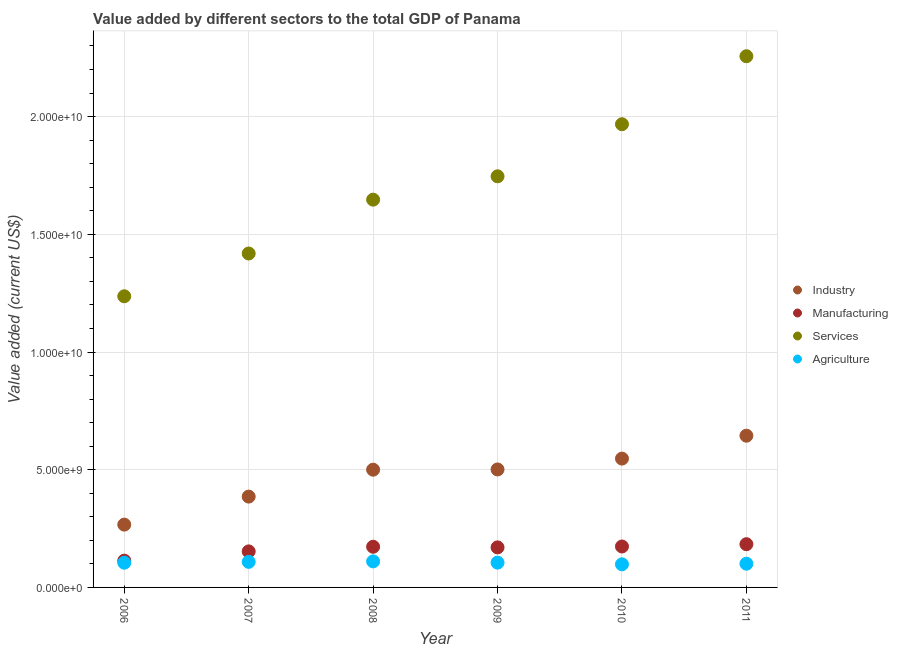Is the number of dotlines equal to the number of legend labels?
Provide a succinct answer. Yes. What is the value added by industrial sector in 2008?
Keep it short and to the point. 5.00e+09. Across all years, what is the maximum value added by manufacturing sector?
Provide a succinct answer. 1.84e+09. Across all years, what is the minimum value added by agricultural sector?
Your answer should be compact. 9.81e+08. What is the total value added by agricultural sector in the graph?
Your response must be concise. 6.29e+09. What is the difference between the value added by agricultural sector in 2006 and that in 2009?
Give a very brief answer. -3.70e+06. What is the difference between the value added by manufacturing sector in 2011 and the value added by services sector in 2006?
Give a very brief answer. -1.05e+1. What is the average value added by manufacturing sector per year?
Your response must be concise. 1.61e+09. In the year 2010, what is the difference between the value added by services sector and value added by agricultural sector?
Give a very brief answer. 1.87e+1. What is the ratio of the value added by agricultural sector in 2007 to that in 2011?
Keep it short and to the point. 1.08. Is the difference between the value added by agricultural sector in 2009 and 2011 greater than the difference between the value added by manufacturing sector in 2009 and 2011?
Make the answer very short. Yes. What is the difference between the highest and the second highest value added by manufacturing sector?
Offer a very short reply. 9.76e+07. What is the difference between the highest and the lowest value added by manufacturing sector?
Make the answer very short. 6.99e+08. In how many years, is the value added by manufacturing sector greater than the average value added by manufacturing sector taken over all years?
Give a very brief answer. 4. Is the sum of the value added by services sector in 2006 and 2007 greater than the maximum value added by industrial sector across all years?
Make the answer very short. Yes. Is it the case that in every year, the sum of the value added by agricultural sector and value added by manufacturing sector is greater than the sum of value added by industrial sector and value added by services sector?
Provide a short and direct response. No. Does the value added by industrial sector monotonically increase over the years?
Your answer should be very brief. Yes. How many dotlines are there?
Provide a short and direct response. 4. What is the difference between two consecutive major ticks on the Y-axis?
Offer a terse response. 5.00e+09. Are the values on the major ticks of Y-axis written in scientific E-notation?
Offer a very short reply. Yes. Does the graph contain grids?
Keep it short and to the point. Yes. Where does the legend appear in the graph?
Provide a succinct answer. Center right. How are the legend labels stacked?
Offer a very short reply. Vertical. What is the title of the graph?
Offer a very short reply. Value added by different sectors to the total GDP of Panama. What is the label or title of the X-axis?
Offer a very short reply. Year. What is the label or title of the Y-axis?
Offer a very short reply. Value added (current US$). What is the Value added (current US$) of Industry in 2006?
Ensure brevity in your answer.  2.67e+09. What is the Value added (current US$) of Manufacturing in 2006?
Offer a very short reply. 1.14e+09. What is the Value added (current US$) of Services in 2006?
Your answer should be very brief. 1.24e+1. What is the Value added (current US$) in Agriculture in 2006?
Ensure brevity in your answer.  1.05e+09. What is the Value added (current US$) of Industry in 2007?
Your answer should be compact. 3.86e+09. What is the Value added (current US$) in Manufacturing in 2007?
Keep it short and to the point. 1.53e+09. What is the Value added (current US$) in Services in 2007?
Keep it short and to the point. 1.42e+1. What is the Value added (current US$) in Agriculture in 2007?
Offer a terse response. 1.09e+09. What is the Value added (current US$) of Industry in 2008?
Give a very brief answer. 5.00e+09. What is the Value added (current US$) in Manufacturing in 2008?
Give a very brief answer. 1.73e+09. What is the Value added (current US$) of Services in 2008?
Keep it short and to the point. 1.65e+1. What is the Value added (current US$) of Agriculture in 2008?
Provide a short and direct response. 1.11e+09. What is the Value added (current US$) in Industry in 2009?
Offer a very short reply. 5.01e+09. What is the Value added (current US$) of Manufacturing in 2009?
Provide a succinct answer. 1.70e+09. What is the Value added (current US$) of Services in 2009?
Give a very brief answer. 1.75e+1. What is the Value added (current US$) in Agriculture in 2009?
Your response must be concise. 1.05e+09. What is the Value added (current US$) in Industry in 2010?
Keep it short and to the point. 5.47e+09. What is the Value added (current US$) in Manufacturing in 2010?
Ensure brevity in your answer.  1.74e+09. What is the Value added (current US$) of Services in 2010?
Your answer should be very brief. 1.97e+1. What is the Value added (current US$) of Agriculture in 2010?
Your answer should be very brief. 9.81e+08. What is the Value added (current US$) in Industry in 2011?
Your answer should be very brief. 6.44e+09. What is the Value added (current US$) in Manufacturing in 2011?
Your answer should be compact. 1.84e+09. What is the Value added (current US$) in Services in 2011?
Your answer should be compact. 2.26e+1. What is the Value added (current US$) in Agriculture in 2011?
Offer a terse response. 1.01e+09. Across all years, what is the maximum Value added (current US$) in Industry?
Provide a short and direct response. 6.44e+09. Across all years, what is the maximum Value added (current US$) in Manufacturing?
Provide a short and direct response. 1.84e+09. Across all years, what is the maximum Value added (current US$) of Services?
Offer a very short reply. 2.26e+1. Across all years, what is the maximum Value added (current US$) in Agriculture?
Make the answer very short. 1.11e+09. Across all years, what is the minimum Value added (current US$) of Industry?
Keep it short and to the point. 2.67e+09. Across all years, what is the minimum Value added (current US$) in Manufacturing?
Offer a very short reply. 1.14e+09. Across all years, what is the minimum Value added (current US$) in Services?
Keep it short and to the point. 1.24e+1. Across all years, what is the minimum Value added (current US$) of Agriculture?
Ensure brevity in your answer.  9.81e+08. What is the total Value added (current US$) in Industry in the graph?
Offer a very short reply. 2.85e+1. What is the total Value added (current US$) of Manufacturing in the graph?
Your answer should be compact. 9.67e+09. What is the total Value added (current US$) of Services in the graph?
Keep it short and to the point. 1.03e+11. What is the total Value added (current US$) in Agriculture in the graph?
Ensure brevity in your answer.  6.29e+09. What is the difference between the Value added (current US$) of Industry in 2006 and that in 2007?
Provide a succinct answer. -1.19e+09. What is the difference between the Value added (current US$) in Manufacturing in 2006 and that in 2007?
Offer a terse response. -3.93e+08. What is the difference between the Value added (current US$) of Services in 2006 and that in 2007?
Your response must be concise. -1.82e+09. What is the difference between the Value added (current US$) of Agriculture in 2006 and that in 2007?
Your response must be concise. -3.64e+07. What is the difference between the Value added (current US$) in Industry in 2006 and that in 2008?
Your answer should be very brief. -2.33e+09. What is the difference between the Value added (current US$) in Manufacturing in 2006 and that in 2008?
Keep it short and to the point. -5.90e+08. What is the difference between the Value added (current US$) of Services in 2006 and that in 2008?
Your answer should be very brief. -4.10e+09. What is the difference between the Value added (current US$) in Agriculture in 2006 and that in 2008?
Your response must be concise. -5.68e+07. What is the difference between the Value added (current US$) in Industry in 2006 and that in 2009?
Keep it short and to the point. -2.34e+09. What is the difference between the Value added (current US$) in Manufacturing in 2006 and that in 2009?
Make the answer very short. -5.63e+08. What is the difference between the Value added (current US$) in Services in 2006 and that in 2009?
Your response must be concise. -5.10e+09. What is the difference between the Value added (current US$) in Agriculture in 2006 and that in 2009?
Ensure brevity in your answer.  -3.70e+06. What is the difference between the Value added (current US$) of Industry in 2006 and that in 2010?
Provide a short and direct response. -2.80e+09. What is the difference between the Value added (current US$) in Manufacturing in 2006 and that in 2010?
Offer a terse response. -6.02e+08. What is the difference between the Value added (current US$) of Services in 2006 and that in 2010?
Your answer should be very brief. -7.31e+09. What is the difference between the Value added (current US$) of Agriculture in 2006 and that in 2010?
Give a very brief answer. 6.85e+07. What is the difference between the Value added (current US$) of Industry in 2006 and that in 2011?
Make the answer very short. -3.78e+09. What is the difference between the Value added (current US$) in Manufacturing in 2006 and that in 2011?
Your answer should be compact. -6.99e+08. What is the difference between the Value added (current US$) of Services in 2006 and that in 2011?
Your answer should be compact. -1.02e+1. What is the difference between the Value added (current US$) in Agriculture in 2006 and that in 2011?
Your answer should be compact. 4.21e+07. What is the difference between the Value added (current US$) of Industry in 2007 and that in 2008?
Your answer should be compact. -1.14e+09. What is the difference between the Value added (current US$) in Manufacturing in 2007 and that in 2008?
Provide a short and direct response. -1.97e+08. What is the difference between the Value added (current US$) in Services in 2007 and that in 2008?
Give a very brief answer. -2.29e+09. What is the difference between the Value added (current US$) in Agriculture in 2007 and that in 2008?
Your answer should be very brief. -2.04e+07. What is the difference between the Value added (current US$) in Industry in 2007 and that in 2009?
Keep it short and to the point. -1.15e+09. What is the difference between the Value added (current US$) of Manufacturing in 2007 and that in 2009?
Ensure brevity in your answer.  -1.70e+08. What is the difference between the Value added (current US$) of Services in 2007 and that in 2009?
Your answer should be compact. -3.28e+09. What is the difference between the Value added (current US$) in Agriculture in 2007 and that in 2009?
Your answer should be very brief. 3.27e+07. What is the difference between the Value added (current US$) in Industry in 2007 and that in 2010?
Your response must be concise. -1.61e+09. What is the difference between the Value added (current US$) in Manufacturing in 2007 and that in 2010?
Provide a succinct answer. -2.08e+08. What is the difference between the Value added (current US$) of Services in 2007 and that in 2010?
Your response must be concise. -5.49e+09. What is the difference between the Value added (current US$) of Agriculture in 2007 and that in 2010?
Provide a succinct answer. 1.05e+08. What is the difference between the Value added (current US$) of Industry in 2007 and that in 2011?
Give a very brief answer. -2.59e+09. What is the difference between the Value added (current US$) in Manufacturing in 2007 and that in 2011?
Ensure brevity in your answer.  -3.06e+08. What is the difference between the Value added (current US$) in Services in 2007 and that in 2011?
Your answer should be compact. -8.38e+09. What is the difference between the Value added (current US$) in Agriculture in 2007 and that in 2011?
Offer a terse response. 7.85e+07. What is the difference between the Value added (current US$) of Industry in 2008 and that in 2009?
Give a very brief answer. -1.00e+07. What is the difference between the Value added (current US$) in Manufacturing in 2008 and that in 2009?
Ensure brevity in your answer.  2.71e+07. What is the difference between the Value added (current US$) of Services in 2008 and that in 2009?
Offer a very short reply. -9.91e+08. What is the difference between the Value added (current US$) in Agriculture in 2008 and that in 2009?
Provide a succinct answer. 5.31e+07. What is the difference between the Value added (current US$) in Industry in 2008 and that in 2010?
Offer a terse response. -4.71e+08. What is the difference between the Value added (current US$) of Manufacturing in 2008 and that in 2010?
Offer a terse response. -1.11e+07. What is the difference between the Value added (current US$) of Services in 2008 and that in 2010?
Provide a short and direct response. -3.20e+09. What is the difference between the Value added (current US$) in Agriculture in 2008 and that in 2010?
Keep it short and to the point. 1.25e+08. What is the difference between the Value added (current US$) in Industry in 2008 and that in 2011?
Provide a succinct answer. -1.44e+09. What is the difference between the Value added (current US$) of Manufacturing in 2008 and that in 2011?
Keep it short and to the point. -1.09e+08. What is the difference between the Value added (current US$) of Services in 2008 and that in 2011?
Provide a short and direct response. -6.09e+09. What is the difference between the Value added (current US$) of Agriculture in 2008 and that in 2011?
Provide a succinct answer. 9.89e+07. What is the difference between the Value added (current US$) of Industry in 2009 and that in 2010?
Provide a short and direct response. -4.61e+08. What is the difference between the Value added (current US$) of Manufacturing in 2009 and that in 2010?
Your answer should be very brief. -3.82e+07. What is the difference between the Value added (current US$) of Services in 2009 and that in 2010?
Give a very brief answer. -2.21e+09. What is the difference between the Value added (current US$) of Agriculture in 2009 and that in 2010?
Provide a short and direct response. 7.22e+07. What is the difference between the Value added (current US$) in Industry in 2009 and that in 2011?
Your response must be concise. -1.43e+09. What is the difference between the Value added (current US$) of Manufacturing in 2009 and that in 2011?
Offer a very short reply. -1.36e+08. What is the difference between the Value added (current US$) of Services in 2009 and that in 2011?
Offer a very short reply. -5.10e+09. What is the difference between the Value added (current US$) in Agriculture in 2009 and that in 2011?
Give a very brief answer. 4.58e+07. What is the difference between the Value added (current US$) in Industry in 2010 and that in 2011?
Your answer should be compact. -9.72e+08. What is the difference between the Value added (current US$) in Manufacturing in 2010 and that in 2011?
Provide a short and direct response. -9.76e+07. What is the difference between the Value added (current US$) in Services in 2010 and that in 2011?
Provide a succinct answer. -2.89e+09. What is the difference between the Value added (current US$) of Agriculture in 2010 and that in 2011?
Your answer should be very brief. -2.64e+07. What is the difference between the Value added (current US$) in Industry in 2006 and the Value added (current US$) in Manufacturing in 2007?
Your answer should be very brief. 1.14e+09. What is the difference between the Value added (current US$) in Industry in 2006 and the Value added (current US$) in Services in 2007?
Your response must be concise. -1.15e+1. What is the difference between the Value added (current US$) of Industry in 2006 and the Value added (current US$) of Agriculture in 2007?
Your response must be concise. 1.58e+09. What is the difference between the Value added (current US$) of Manufacturing in 2006 and the Value added (current US$) of Services in 2007?
Provide a succinct answer. -1.30e+1. What is the difference between the Value added (current US$) of Manufacturing in 2006 and the Value added (current US$) of Agriculture in 2007?
Offer a very short reply. 5.13e+07. What is the difference between the Value added (current US$) of Services in 2006 and the Value added (current US$) of Agriculture in 2007?
Make the answer very short. 1.13e+1. What is the difference between the Value added (current US$) in Industry in 2006 and the Value added (current US$) in Manufacturing in 2008?
Provide a short and direct response. 9.40e+08. What is the difference between the Value added (current US$) in Industry in 2006 and the Value added (current US$) in Services in 2008?
Make the answer very short. -1.38e+1. What is the difference between the Value added (current US$) in Industry in 2006 and the Value added (current US$) in Agriculture in 2008?
Offer a terse response. 1.56e+09. What is the difference between the Value added (current US$) of Manufacturing in 2006 and the Value added (current US$) of Services in 2008?
Offer a terse response. -1.53e+1. What is the difference between the Value added (current US$) of Manufacturing in 2006 and the Value added (current US$) of Agriculture in 2008?
Your answer should be very brief. 3.09e+07. What is the difference between the Value added (current US$) of Services in 2006 and the Value added (current US$) of Agriculture in 2008?
Give a very brief answer. 1.13e+1. What is the difference between the Value added (current US$) of Industry in 2006 and the Value added (current US$) of Manufacturing in 2009?
Ensure brevity in your answer.  9.67e+08. What is the difference between the Value added (current US$) of Industry in 2006 and the Value added (current US$) of Services in 2009?
Offer a very short reply. -1.48e+1. What is the difference between the Value added (current US$) of Industry in 2006 and the Value added (current US$) of Agriculture in 2009?
Your answer should be compact. 1.61e+09. What is the difference between the Value added (current US$) of Manufacturing in 2006 and the Value added (current US$) of Services in 2009?
Ensure brevity in your answer.  -1.63e+1. What is the difference between the Value added (current US$) in Manufacturing in 2006 and the Value added (current US$) in Agriculture in 2009?
Make the answer very short. 8.40e+07. What is the difference between the Value added (current US$) of Services in 2006 and the Value added (current US$) of Agriculture in 2009?
Give a very brief answer. 1.13e+1. What is the difference between the Value added (current US$) of Industry in 2006 and the Value added (current US$) of Manufacturing in 2010?
Keep it short and to the point. 9.29e+08. What is the difference between the Value added (current US$) of Industry in 2006 and the Value added (current US$) of Services in 2010?
Make the answer very short. -1.70e+1. What is the difference between the Value added (current US$) in Industry in 2006 and the Value added (current US$) in Agriculture in 2010?
Provide a succinct answer. 1.69e+09. What is the difference between the Value added (current US$) in Manufacturing in 2006 and the Value added (current US$) in Services in 2010?
Your answer should be very brief. -1.85e+1. What is the difference between the Value added (current US$) in Manufacturing in 2006 and the Value added (current US$) in Agriculture in 2010?
Offer a very short reply. 1.56e+08. What is the difference between the Value added (current US$) in Services in 2006 and the Value added (current US$) in Agriculture in 2010?
Your response must be concise. 1.14e+1. What is the difference between the Value added (current US$) of Industry in 2006 and the Value added (current US$) of Manufacturing in 2011?
Your answer should be very brief. 8.31e+08. What is the difference between the Value added (current US$) in Industry in 2006 and the Value added (current US$) in Services in 2011?
Offer a very short reply. -1.99e+1. What is the difference between the Value added (current US$) of Industry in 2006 and the Value added (current US$) of Agriculture in 2011?
Ensure brevity in your answer.  1.66e+09. What is the difference between the Value added (current US$) in Manufacturing in 2006 and the Value added (current US$) in Services in 2011?
Provide a succinct answer. -2.14e+1. What is the difference between the Value added (current US$) in Manufacturing in 2006 and the Value added (current US$) in Agriculture in 2011?
Offer a terse response. 1.30e+08. What is the difference between the Value added (current US$) of Services in 2006 and the Value added (current US$) of Agriculture in 2011?
Provide a short and direct response. 1.14e+1. What is the difference between the Value added (current US$) in Industry in 2007 and the Value added (current US$) in Manufacturing in 2008?
Give a very brief answer. 2.13e+09. What is the difference between the Value added (current US$) of Industry in 2007 and the Value added (current US$) of Services in 2008?
Ensure brevity in your answer.  -1.26e+1. What is the difference between the Value added (current US$) in Industry in 2007 and the Value added (current US$) in Agriculture in 2008?
Offer a very short reply. 2.75e+09. What is the difference between the Value added (current US$) in Manufacturing in 2007 and the Value added (current US$) in Services in 2008?
Keep it short and to the point. -1.49e+1. What is the difference between the Value added (current US$) in Manufacturing in 2007 and the Value added (current US$) in Agriculture in 2008?
Make the answer very short. 4.24e+08. What is the difference between the Value added (current US$) of Services in 2007 and the Value added (current US$) of Agriculture in 2008?
Give a very brief answer. 1.31e+1. What is the difference between the Value added (current US$) in Industry in 2007 and the Value added (current US$) in Manufacturing in 2009?
Keep it short and to the point. 2.16e+09. What is the difference between the Value added (current US$) in Industry in 2007 and the Value added (current US$) in Services in 2009?
Ensure brevity in your answer.  -1.36e+1. What is the difference between the Value added (current US$) of Industry in 2007 and the Value added (current US$) of Agriculture in 2009?
Offer a terse response. 2.80e+09. What is the difference between the Value added (current US$) of Manufacturing in 2007 and the Value added (current US$) of Services in 2009?
Your answer should be compact. -1.59e+1. What is the difference between the Value added (current US$) of Manufacturing in 2007 and the Value added (current US$) of Agriculture in 2009?
Provide a short and direct response. 4.77e+08. What is the difference between the Value added (current US$) of Services in 2007 and the Value added (current US$) of Agriculture in 2009?
Give a very brief answer. 1.31e+1. What is the difference between the Value added (current US$) of Industry in 2007 and the Value added (current US$) of Manufacturing in 2010?
Your response must be concise. 2.12e+09. What is the difference between the Value added (current US$) of Industry in 2007 and the Value added (current US$) of Services in 2010?
Offer a very short reply. -1.58e+1. What is the difference between the Value added (current US$) in Industry in 2007 and the Value added (current US$) in Agriculture in 2010?
Make the answer very short. 2.88e+09. What is the difference between the Value added (current US$) in Manufacturing in 2007 and the Value added (current US$) in Services in 2010?
Provide a short and direct response. -1.81e+1. What is the difference between the Value added (current US$) of Manufacturing in 2007 and the Value added (current US$) of Agriculture in 2010?
Ensure brevity in your answer.  5.49e+08. What is the difference between the Value added (current US$) in Services in 2007 and the Value added (current US$) in Agriculture in 2010?
Offer a terse response. 1.32e+1. What is the difference between the Value added (current US$) in Industry in 2007 and the Value added (current US$) in Manufacturing in 2011?
Make the answer very short. 2.02e+09. What is the difference between the Value added (current US$) of Industry in 2007 and the Value added (current US$) of Services in 2011?
Offer a terse response. -1.87e+1. What is the difference between the Value added (current US$) of Industry in 2007 and the Value added (current US$) of Agriculture in 2011?
Your response must be concise. 2.85e+09. What is the difference between the Value added (current US$) of Manufacturing in 2007 and the Value added (current US$) of Services in 2011?
Your response must be concise. -2.10e+1. What is the difference between the Value added (current US$) of Manufacturing in 2007 and the Value added (current US$) of Agriculture in 2011?
Give a very brief answer. 5.23e+08. What is the difference between the Value added (current US$) of Services in 2007 and the Value added (current US$) of Agriculture in 2011?
Offer a terse response. 1.32e+1. What is the difference between the Value added (current US$) of Industry in 2008 and the Value added (current US$) of Manufacturing in 2009?
Your answer should be very brief. 3.30e+09. What is the difference between the Value added (current US$) in Industry in 2008 and the Value added (current US$) in Services in 2009?
Your answer should be compact. -1.25e+1. What is the difference between the Value added (current US$) of Industry in 2008 and the Value added (current US$) of Agriculture in 2009?
Your answer should be very brief. 3.95e+09. What is the difference between the Value added (current US$) in Manufacturing in 2008 and the Value added (current US$) in Services in 2009?
Your response must be concise. -1.57e+1. What is the difference between the Value added (current US$) of Manufacturing in 2008 and the Value added (current US$) of Agriculture in 2009?
Your response must be concise. 6.74e+08. What is the difference between the Value added (current US$) of Services in 2008 and the Value added (current US$) of Agriculture in 2009?
Your response must be concise. 1.54e+1. What is the difference between the Value added (current US$) in Industry in 2008 and the Value added (current US$) in Manufacturing in 2010?
Provide a short and direct response. 3.26e+09. What is the difference between the Value added (current US$) of Industry in 2008 and the Value added (current US$) of Services in 2010?
Offer a very short reply. -1.47e+1. What is the difference between the Value added (current US$) in Industry in 2008 and the Value added (current US$) in Agriculture in 2010?
Provide a succinct answer. 4.02e+09. What is the difference between the Value added (current US$) in Manufacturing in 2008 and the Value added (current US$) in Services in 2010?
Offer a terse response. -1.79e+1. What is the difference between the Value added (current US$) in Manufacturing in 2008 and the Value added (current US$) in Agriculture in 2010?
Offer a very short reply. 7.47e+08. What is the difference between the Value added (current US$) of Services in 2008 and the Value added (current US$) of Agriculture in 2010?
Make the answer very short. 1.55e+1. What is the difference between the Value added (current US$) in Industry in 2008 and the Value added (current US$) in Manufacturing in 2011?
Provide a succinct answer. 3.16e+09. What is the difference between the Value added (current US$) in Industry in 2008 and the Value added (current US$) in Services in 2011?
Provide a short and direct response. -1.76e+1. What is the difference between the Value added (current US$) of Industry in 2008 and the Value added (current US$) of Agriculture in 2011?
Provide a succinct answer. 3.99e+09. What is the difference between the Value added (current US$) of Manufacturing in 2008 and the Value added (current US$) of Services in 2011?
Make the answer very short. -2.08e+1. What is the difference between the Value added (current US$) in Manufacturing in 2008 and the Value added (current US$) in Agriculture in 2011?
Your response must be concise. 7.20e+08. What is the difference between the Value added (current US$) of Services in 2008 and the Value added (current US$) of Agriculture in 2011?
Your answer should be compact. 1.55e+1. What is the difference between the Value added (current US$) of Industry in 2009 and the Value added (current US$) of Manufacturing in 2010?
Keep it short and to the point. 3.27e+09. What is the difference between the Value added (current US$) of Industry in 2009 and the Value added (current US$) of Services in 2010?
Give a very brief answer. -1.47e+1. What is the difference between the Value added (current US$) of Industry in 2009 and the Value added (current US$) of Agriculture in 2010?
Offer a very short reply. 4.03e+09. What is the difference between the Value added (current US$) in Manufacturing in 2009 and the Value added (current US$) in Services in 2010?
Provide a short and direct response. -1.80e+1. What is the difference between the Value added (current US$) of Manufacturing in 2009 and the Value added (current US$) of Agriculture in 2010?
Offer a terse response. 7.20e+08. What is the difference between the Value added (current US$) of Services in 2009 and the Value added (current US$) of Agriculture in 2010?
Your response must be concise. 1.65e+1. What is the difference between the Value added (current US$) in Industry in 2009 and the Value added (current US$) in Manufacturing in 2011?
Your response must be concise. 3.17e+09. What is the difference between the Value added (current US$) of Industry in 2009 and the Value added (current US$) of Services in 2011?
Provide a short and direct response. -1.76e+1. What is the difference between the Value added (current US$) in Industry in 2009 and the Value added (current US$) in Agriculture in 2011?
Make the answer very short. 4.00e+09. What is the difference between the Value added (current US$) of Manufacturing in 2009 and the Value added (current US$) of Services in 2011?
Offer a very short reply. -2.09e+1. What is the difference between the Value added (current US$) of Manufacturing in 2009 and the Value added (current US$) of Agriculture in 2011?
Provide a succinct answer. 6.93e+08. What is the difference between the Value added (current US$) in Services in 2009 and the Value added (current US$) in Agriculture in 2011?
Your response must be concise. 1.65e+1. What is the difference between the Value added (current US$) of Industry in 2010 and the Value added (current US$) of Manufacturing in 2011?
Ensure brevity in your answer.  3.64e+09. What is the difference between the Value added (current US$) of Industry in 2010 and the Value added (current US$) of Services in 2011?
Offer a very short reply. -1.71e+1. What is the difference between the Value added (current US$) of Industry in 2010 and the Value added (current US$) of Agriculture in 2011?
Your response must be concise. 4.46e+09. What is the difference between the Value added (current US$) of Manufacturing in 2010 and the Value added (current US$) of Services in 2011?
Keep it short and to the point. -2.08e+1. What is the difference between the Value added (current US$) in Manufacturing in 2010 and the Value added (current US$) in Agriculture in 2011?
Offer a very short reply. 7.31e+08. What is the difference between the Value added (current US$) of Services in 2010 and the Value added (current US$) of Agriculture in 2011?
Keep it short and to the point. 1.87e+1. What is the average Value added (current US$) in Industry per year?
Offer a very short reply. 4.74e+09. What is the average Value added (current US$) of Manufacturing per year?
Offer a very short reply. 1.61e+09. What is the average Value added (current US$) in Services per year?
Your answer should be compact. 1.71e+1. What is the average Value added (current US$) in Agriculture per year?
Keep it short and to the point. 1.05e+09. In the year 2006, what is the difference between the Value added (current US$) of Industry and Value added (current US$) of Manufacturing?
Make the answer very short. 1.53e+09. In the year 2006, what is the difference between the Value added (current US$) of Industry and Value added (current US$) of Services?
Your response must be concise. -9.70e+09. In the year 2006, what is the difference between the Value added (current US$) of Industry and Value added (current US$) of Agriculture?
Offer a terse response. 1.62e+09. In the year 2006, what is the difference between the Value added (current US$) in Manufacturing and Value added (current US$) in Services?
Ensure brevity in your answer.  -1.12e+1. In the year 2006, what is the difference between the Value added (current US$) in Manufacturing and Value added (current US$) in Agriculture?
Your answer should be very brief. 8.77e+07. In the year 2006, what is the difference between the Value added (current US$) in Services and Value added (current US$) in Agriculture?
Your answer should be compact. 1.13e+1. In the year 2007, what is the difference between the Value added (current US$) of Industry and Value added (current US$) of Manufacturing?
Your answer should be compact. 2.33e+09. In the year 2007, what is the difference between the Value added (current US$) in Industry and Value added (current US$) in Services?
Your response must be concise. -1.03e+1. In the year 2007, what is the difference between the Value added (current US$) of Industry and Value added (current US$) of Agriculture?
Provide a short and direct response. 2.77e+09. In the year 2007, what is the difference between the Value added (current US$) of Manufacturing and Value added (current US$) of Services?
Ensure brevity in your answer.  -1.27e+1. In the year 2007, what is the difference between the Value added (current US$) in Manufacturing and Value added (current US$) in Agriculture?
Keep it short and to the point. 4.44e+08. In the year 2007, what is the difference between the Value added (current US$) of Services and Value added (current US$) of Agriculture?
Make the answer very short. 1.31e+1. In the year 2008, what is the difference between the Value added (current US$) of Industry and Value added (current US$) of Manufacturing?
Make the answer very short. 3.27e+09. In the year 2008, what is the difference between the Value added (current US$) in Industry and Value added (current US$) in Services?
Your answer should be compact. -1.15e+1. In the year 2008, what is the difference between the Value added (current US$) of Industry and Value added (current US$) of Agriculture?
Your answer should be compact. 3.89e+09. In the year 2008, what is the difference between the Value added (current US$) in Manufacturing and Value added (current US$) in Services?
Your answer should be compact. -1.47e+1. In the year 2008, what is the difference between the Value added (current US$) of Manufacturing and Value added (current US$) of Agriculture?
Offer a very short reply. 6.21e+08. In the year 2008, what is the difference between the Value added (current US$) of Services and Value added (current US$) of Agriculture?
Your response must be concise. 1.54e+1. In the year 2009, what is the difference between the Value added (current US$) of Industry and Value added (current US$) of Manufacturing?
Your answer should be very brief. 3.31e+09. In the year 2009, what is the difference between the Value added (current US$) of Industry and Value added (current US$) of Services?
Your response must be concise. -1.25e+1. In the year 2009, what is the difference between the Value added (current US$) in Industry and Value added (current US$) in Agriculture?
Offer a terse response. 3.96e+09. In the year 2009, what is the difference between the Value added (current US$) of Manufacturing and Value added (current US$) of Services?
Keep it short and to the point. -1.58e+1. In the year 2009, what is the difference between the Value added (current US$) in Manufacturing and Value added (current US$) in Agriculture?
Your answer should be very brief. 6.47e+08. In the year 2009, what is the difference between the Value added (current US$) in Services and Value added (current US$) in Agriculture?
Offer a terse response. 1.64e+1. In the year 2010, what is the difference between the Value added (current US$) of Industry and Value added (current US$) of Manufacturing?
Keep it short and to the point. 3.73e+09. In the year 2010, what is the difference between the Value added (current US$) in Industry and Value added (current US$) in Services?
Provide a succinct answer. -1.42e+1. In the year 2010, what is the difference between the Value added (current US$) of Industry and Value added (current US$) of Agriculture?
Offer a very short reply. 4.49e+09. In the year 2010, what is the difference between the Value added (current US$) in Manufacturing and Value added (current US$) in Services?
Make the answer very short. -1.79e+1. In the year 2010, what is the difference between the Value added (current US$) in Manufacturing and Value added (current US$) in Agriculture?
Make the answer very short. 7.58e+08. In the year 2010, what is the difference between the Value added (current US$) in Services and Value added (current US$) in Agriculture?
Your response must be concise. 1.87e+1. In the year 2011, what is the difference between the Value added (current US$) of Industry and Value added (current US$) of Manufacturing?
Your response must be concise. 4.61e+09. In the year 2011, what is the difference between the Value added (current US$) of Industry and Value added (current US$) of Services?
Your answer should be compact. -1.61e+1. In the year 2011, what is the difference between the Value added (current US$) of Industry and Value added (current US$) of Agriculture?
Your answer should be very brief. 5.44e+09. In the year 2011, what is the difference between the Value added (current US$) of Manufacturing and Value added (current US$) of Services?
Offer a terse response. -2.07e+1. In the year 2011, what is the difference between the Value added (current US$) in Manufacturing and Value added (current US$) in Agriculture?
Your response must be concise. 8.29e+08. In the year 2011, what is the difference between the Value added (current US$) in Services and Value added (current US$) in Agriculture?
Provide a short and direct response. 2.16e+1. What is the ratio of the Value added (current US$) in Industry in 2006 to that in 2007?
Provide a succinct answer. 0.69. What is the ratio of the Value added (current US$) in Manufacturing in 2006 to that in 2007?
Your answer should be very brief. 0.74. What is the ratio of the Value added (current US$) in Services in 2006 to that in 2007?
Make the answer very short. 0.87. What is the ratio of the Value added (current US$) in Agriculture in 2006 to that in 2007?
Give a very brief answer. 0.97. What is the ratio of the Value added (current US$) in Industry in 2006 to that in 2008?
Give a very brief answer. 0.53. What is the ratio of the Value added (current US$) in Manufacturing in 2006 to that in 2008?
Give a very brief answer. 0.66. What is the ratio of the Value added (current US$) of Services in 2006 to that in 2008?
Your response must be concise. 0.75. What is the ratio of the Value added (current US$) of Agriculture in 2006 to that in 2008?
Give a very brief answer. 0.95. What is the ratio of the Value added (current US$) in Industry in 2006 to that in 2009?
Your response must be concise. 0.53. What is the ratio of the Value added (current US$) in Manufacturing in 2006 to that in 2009?
Provide a short and direct response. 0.67. What is the ratio of the Value added (current US$) in Services in 2006 to that in 2009?
Your answer should be compact. 0.71. What is the ratio of the Value added (current US$) of Industry in 2006 to that in 2010?
Offer a terse response. 0.49. What is the ratio of the Value added (current US$) in Manufacturing in 2006 to that in 2010?
Offer a very short reply. 0.65. What is the ratio of the Value added (current US$) of Services in 2006 to that in 2010?
Ensure brevity in your answer.  0.63. What is the ratio of the Value added (current US$) in Agriculture in 2006 to that in 2010?
Your answer should be compact. 1.07. What is the ratio of the Value added (current US$) of Industry in 2006 to that in 2011?
Keep it short and to the point. 0.41. What is the ratio of the Value added (current US$) in Manufacturing in 2006 to that in 2011?
Give a very brief answer. 0.62. What is the ratio of the Value added (current US$) of Services in 2006 to that in 2011?
Offer a very short reply. 0.55. What is the ratio of the Value added (current US$) of Agriculture in 2006 to that in 2011?
Your response must be concise. 1.04. What is the ratio of the Value added (current US$) in Industry in 2007 to that in 2008?
Ensure brevity in your answer.  0.77. What is the ratio of the Value added (current US$) in Manufacturing in 2007 to that in 2008?
Provide a short and direct response. 0.89. What is the ratio of the Value added (current US$) of Services in 2007 to that in 2008?
Your response must be concise. 0.86. What is the ratio of the Value added (current US$) in Agriculture in 2007 to that in 2008?
Give a very brief answer. 0.98. What is the ratio of the Value added (current US$) in Industry in 2007 to that in 2009?
Provide a short and direct response. 0.77. What is the ratio of the Value added (current US$) of Manufacturing in 2007 to that in 2009?
Keep it short and to the point. 0.9. What is the ratio of the Value added (current US$) in Services in 2007 to that in 2009?
Your answer should be compact. 0.81. What is the ratio of the Value added (current US$) in Agriculture in 2007 to that in 2009?
Your answer should be very brief. 1.03. What is the ratio of the Value added (current US$) in Industry in 2007 to that in 2010?
Provide a succinct answer. 0.71. What is the ratio of the Value added (current US$) in Manufacturing in 2007 to that in 2010?
Provide a succinct answer. 0.88. What is the ratio of the Value added (current US$) of Services in 2007 to that in 2010?
Your answer should be very brief. 0.72. What is the ratio of the Value added (current US$) of Agriculture in 2007 to that in 2010?
Your response must be concise. 1.11. What is the ratio of the Value added (current US$) of Industry in 2007 to that in 2011?
Keep it short and to the point. 0.6. What is the ratio of the Value added (current US$) of Manufacturing in 2007 to that in 2011?
Your answer should be very brief. 0.83. What is the ratio of the Value added (current US$) of Services in 2007 to that in 2011?
Ensure brevity in your answer.  0.63. What is the ratio of the Value added (current US$) in Agriculture in 2007 to that in 2011?
Your response must be concise. 1.08. What is the ratio of the Value added (current US$) of Manufacturing in 2008 to that in 2009?
Ensure brevity in your answer.  1.02. What is the ratio of the Value added (current US$) in Services in 2008 to that in 2009?
Keep it short and to the point. 0.94. What is the ratio of the Value added (current US$) of Agriculture in 2008 to that in 2009?
Provide a succinct answer. 1.05. What is the ratio of the Value added (current US$) of Industry in 2008 to that in 2010?
Your response must be concise. 0.91. What is the ratio of the Value added (current US$) of Services in 2008 to that in 2010?
Ensure brevity in your answer.  0.84. What is the ratio of the Value added (current US$) in Agriculture in 2008 to that in 2010?
Offer a very short reply. 1.13. What is the ratio of the Value added (current US$) of Industry in 2008 to that in 2011?
Keep it short and to the point. 0.78. What is the ratio of the Value added (current US$) in Manufacturing in 2008 to that in 2011?
Provide a succinct answer. 0.94. What is the ratio of the Value added (current US$) of Services in 2008 to that in 2011?
Provide a succinct answer. 0.73. What is the ratio of the Value added (current US$) of Agriculture in 2008 to that in 2011?
Provide a short and direct response. 1.1. What is the ratio of the Value added (current US$) in Industry in 2009 to that in 2010?
Ensure brevity in your answer.  0.92. What is the ratio of the Value added (current US$) of Services in 2009 to that in 2010?
Ensure brevity in your answer.  0.89. What is the ratio of the Value added (current US$) in Agriculture in 2009 to that in 2010?
Your answer should be very brief. 1.07. What is the ratio of the Value added (current US$) of Industry in 2009 to that in 2011?
Provide a succinct answer. 0.78. What is the ratio of the Value added (current US$) in Manufacturing in 2009 to that in 2011?
Make the answer very short. 0.93. What is the ratio of the Value added (current US$) of Services in 2009 to that in 2011?
Give a very brief answer. 0.77. What is the ratio of the Value added (current US$) in Agriculture in 2009 to that in 2011?
Give a very brief answer. 1.05. What is the ratio of the Value added (current US$) of Industry in 2010 to that in 2011?
Your answer should be very brief. 0.85. What is the ratio of the Value added (current US$) of Manufacturing in 2010 to that in 2011?
Make the answer very short. 0.95. What is the ratio of the Value added (current US$) in Services in 2010 to that in 2011?
Provide a succinct answer. 0.87. What is the ratio of the Value added (current US$) in Agriculture in 2010 to that in 2011?
Make the answer very short. 0.97. What is the difference between the highest and the second highest Value added (current US$) of Industry?
Provide a succinct answer. 9.72e+08. What is the difference between the highest and the second highest Value added (current US$) in Manufacturing?
Provide a short and direct response. 9.76e+07. What is the difference between the highest and the second highest Value added (current US$) in Services?
Offer a very short reply. 2.89e+09. What is the difference between the highest and the second highest Value added (current US$) in Agriculture?
Provide a short and direct response. 2.04e+07. What is the difference between the highest and the lowest Value added (current US$) in Industry?
Provide a short and direct response. 3.78e+09. What is the difference between the highest and the lowest Value added (current US$) in Manufacturing?
Your answer should be compact. 6.99e+08. What is the difference between the highest and the lowest Value added (current US$) in Services?
Your answer should be compact. 1.02e+1. What is the difference between the highest and the lowest Value added (current US$) of Agriculture?
Ensure brevity in your answer.  1.25e+08. 